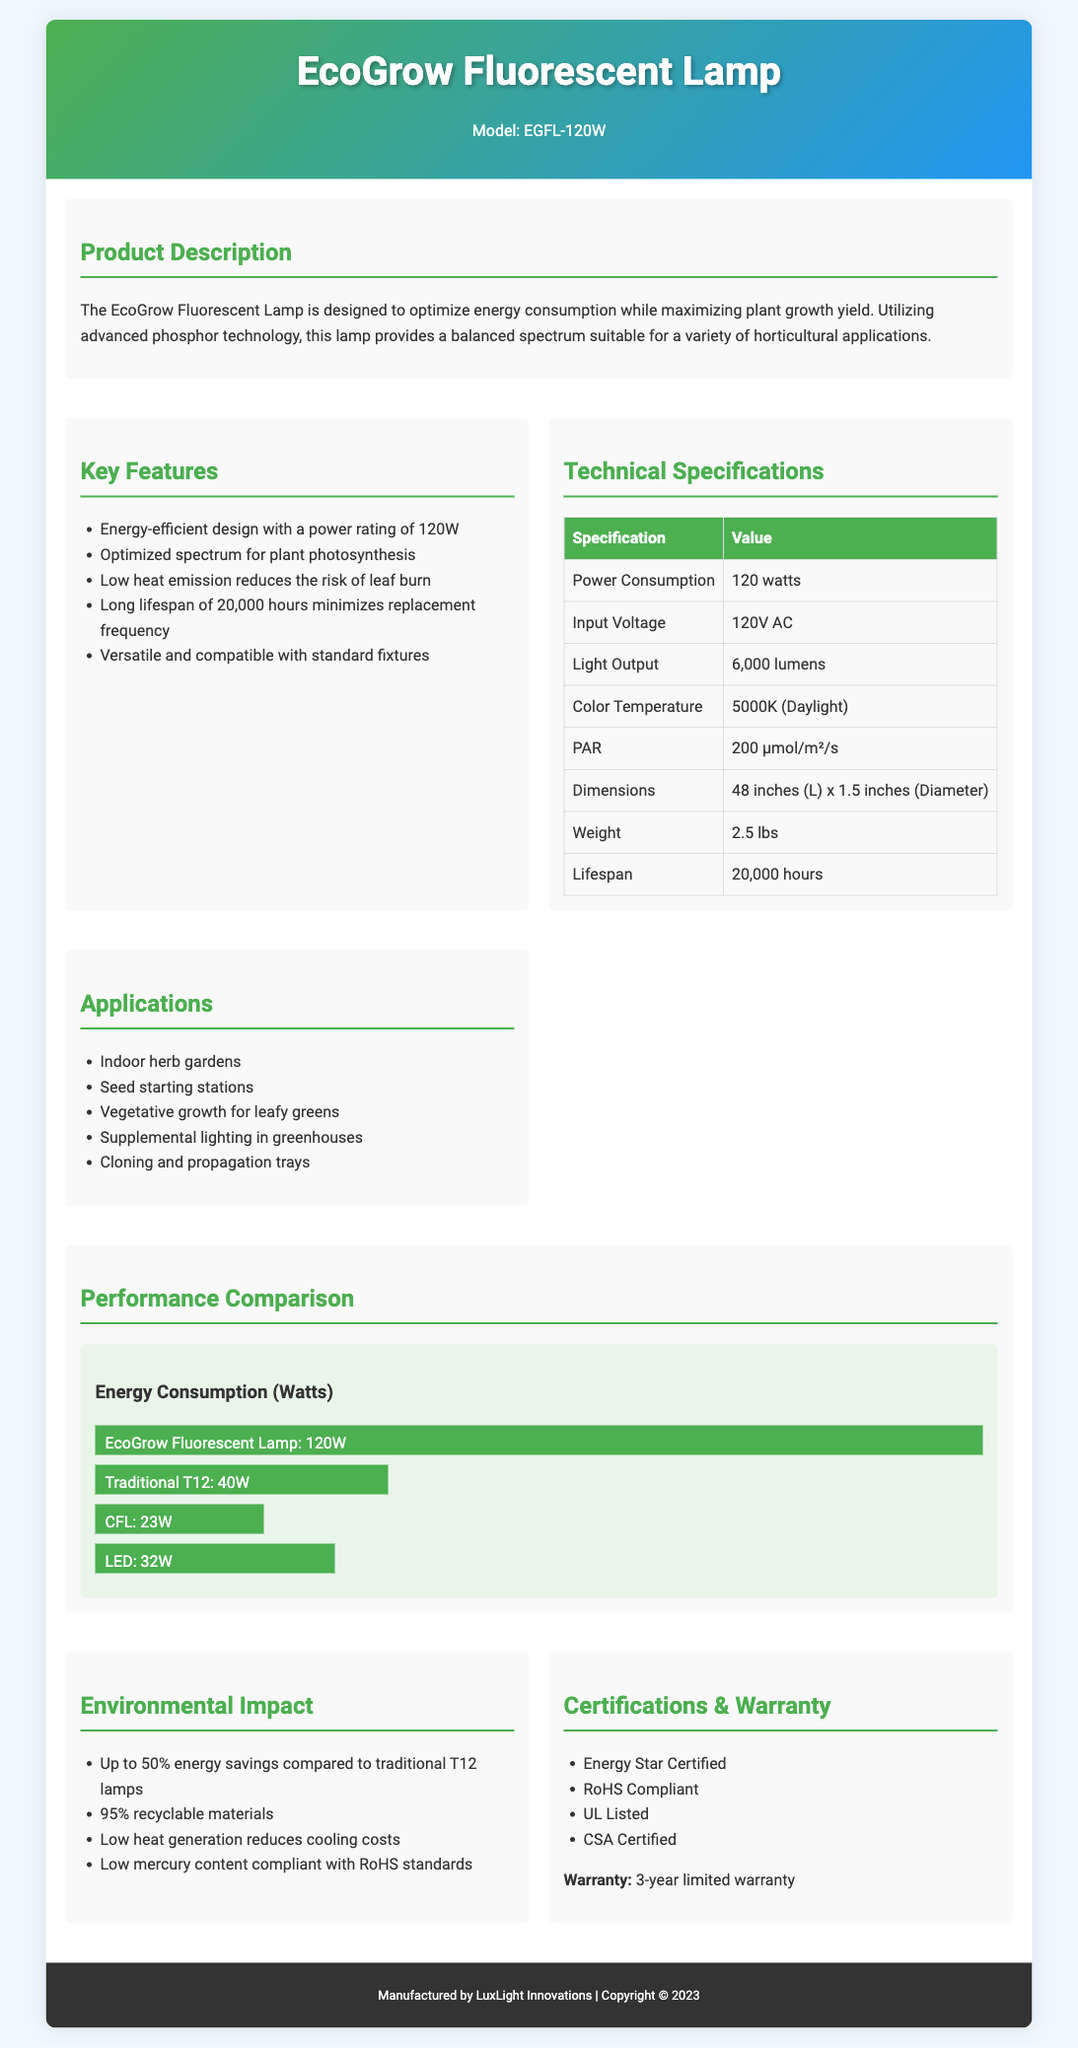What is the power rating of the EcoGrow Fluorescent Lamp? The power rating of the EcoGrow Fluorescent Lamp is directly listed in the specifications as 120W.
Answer: 120W What is the light output of the lamp? The light output is specified in the technical specifications section as 6,000 lumens.
Answer: 6,000 lumens What is the color temperature of the lamp? The color temperature is mentioned in the technical specifications as 5000K (Daylight).
Answer: 5000K (Daylight) How long is the lifespan of the EcoGrow Fluorescent Lamp? The lifespan of the lamp is provided as 20,000 hours in the technical specifications.
Answer: 20,000 hours What percentage of energy savings does the EcoGrow lamp provide compared to traditional T12 lamps? The document states up to 50% energy savings compared to traditional T12 lamps, which is a claim made under environmental impact.
Answer: 50% What type of certification does the EcoGrow Fluorescent Lamp carry? The certifications section lists multiple certifications, including Energy Star Certified, indicating the lamp meets energy efficiency standards.
Answer: Energy Star Certified Which horticultural applications is the lamp suitable for? The applications section includes multiple uses, and one of them is indoor herb gardens which showcase its versatility.
Answer: Indoor herb gardens What is the weight of the EcoGrow Fluorescent Lamp? The weight is specified in the technical specifications as 2.5 lbs.
Answer: 2.5 lbs What year is mentioned in the copyright statement? The copyright statement found in the footer specifies the year as 2023.
Answer: 2023 